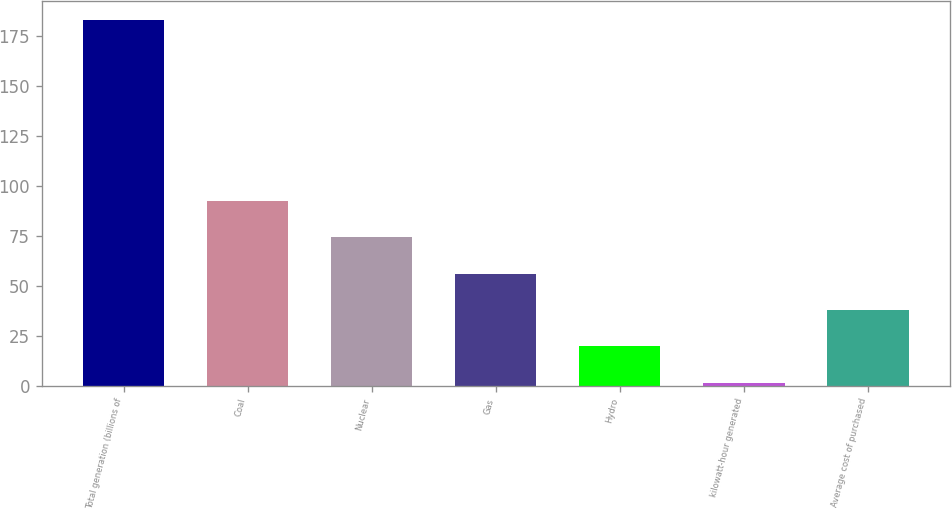Convert chart to OTSL. <chart><loc_0><loc_0><loc_500><loc_500><bar_chart><fcel>Total generation (billions of<fcel>Coal<fcel>Nuclear<fcel>Gas<fcel>Hydro<fcel>kilowatt-hour generated<fcel>Average cost of purchased<nl><fcel>183<fcel>92.28<fcel>74.14<fcel>56<fcel>19.72<fcel>1.58<fcel>37.86<nl></chart> 